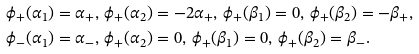<formula> <loc_0><loc_0><loc_500><loc_500>& \phi _ { + } ( \alpha _ { 1 } ) = \alpha _ { + } , \, \phi _ { + } ( \alpha _ { 2 } ) = - 2 \alpha _ { + } , \, \phi _ { + } ( \beta _ { 1 } ) = 0 , \, \phi _ { + } ( \beta _ { 2 } ) = - \beta _ { + } , \\ & \phi _ { - } ( \alpha _ { 1 } ) = \alpha _ { - } , \, \phi _ { + } ( \alpha _ { 2 } ) = 0 , \, \phi _ { + } ( \beta _ { 1 } ) = 0 , \, \phi _ { + } ( \beta _ { 2 } ) = \beta _ { - } .</formula> 